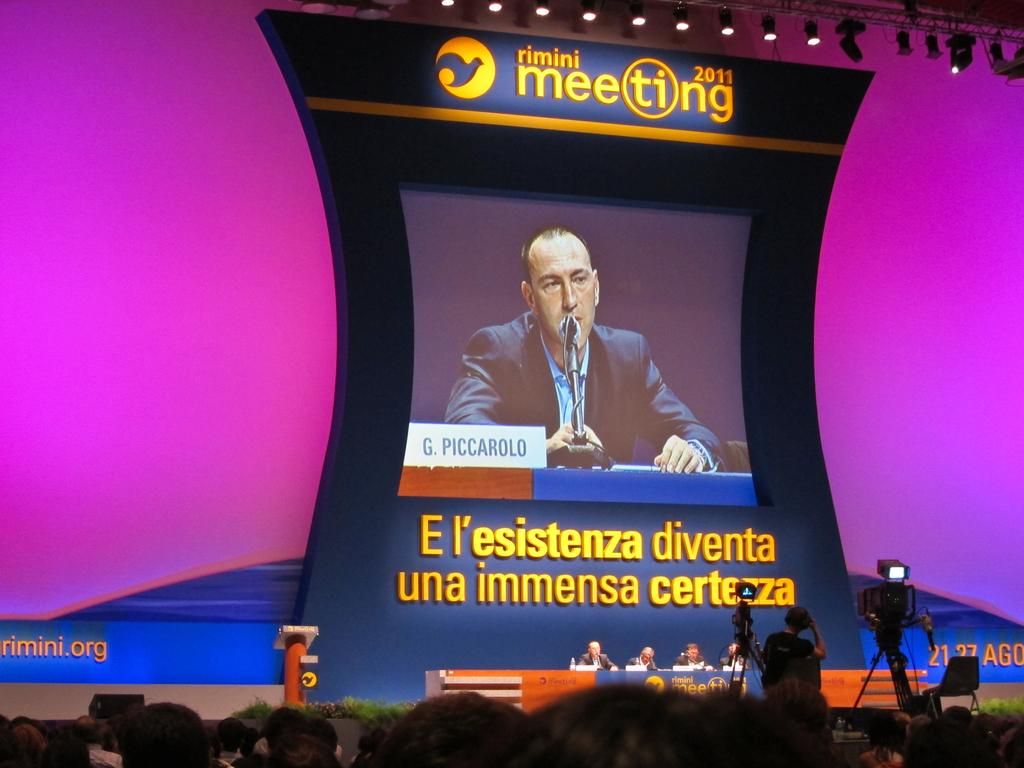What is the main object in the center of the image? There is a screen in the center of the image. What can be seen at the bottom of the image? There are dais, persons, a crowd, and cameras at the bottom of the image. What is visible in the background of the image? There is a wall in the background of the image. How does the magic affect the coal in the image? There is no magic or coal present in the image. Can you tell me how many flights are visible in the image? There are no flights visible in the image. 